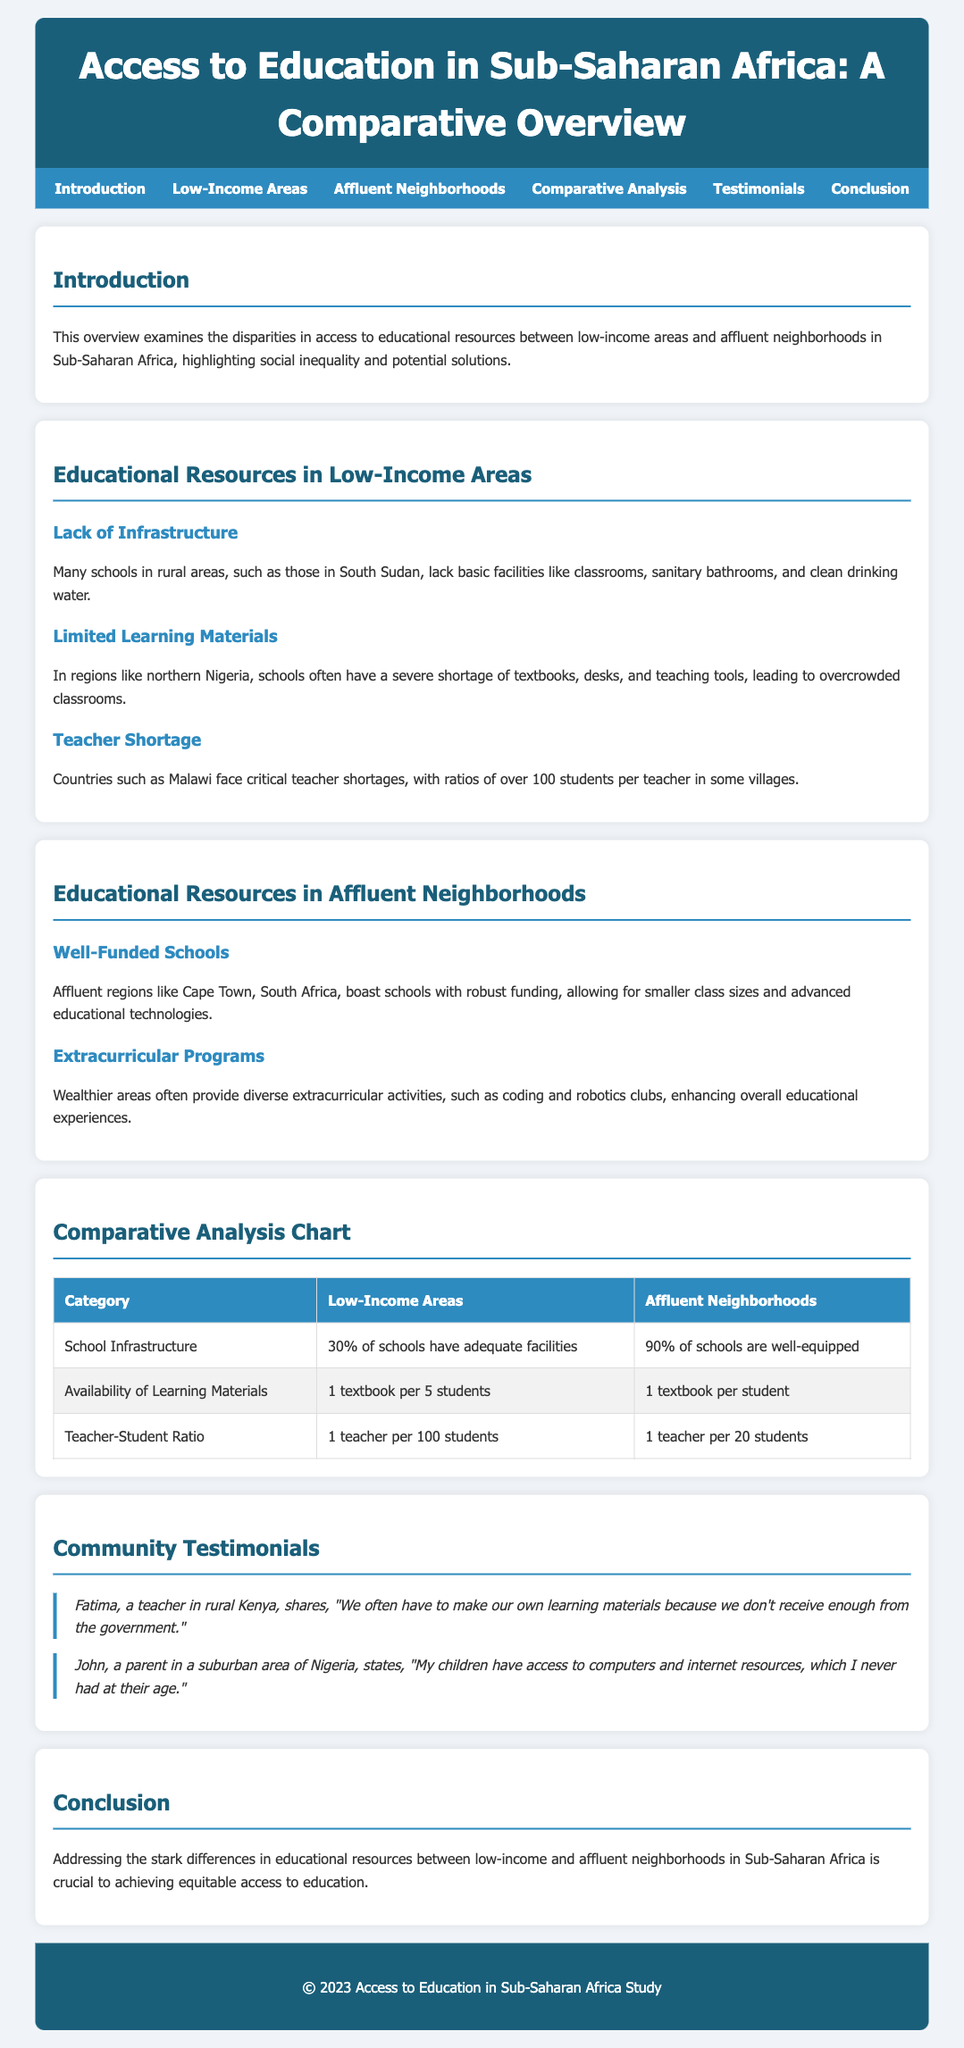What percentage of schools in low-income areas have adequate facilities? The document states that 30% of schools have adequate facilities in low-income areas.
Answer: 30% What is the teacher-student ratio in affluent neighborhoods? According to the comparative analysis chart, the ratio is 1 teacher per 20 students in affluent neighborhoods.
Answer: 1 teacher per 20 students What is one key issue faced by schools in rural South Sudan? The document mentions a lack of infrastructure, including basic facilities like classrooms and sanitary bathrooms.
Answer: Lack of infrastructure Who is Fatima, and what does she mention about learning materials? Fatima is a teacher in rural Kenya who states they often have to make their own learning materials.
Answer: A teacher in rural Kenya How many textbooks are available per student in affluent neighborhoods? The document indicates that there is 1 textbook per student in affluent neighborhoods.
Answer: 1 textbook per student Which area boasts well-funded schools according to the document? The document references Cape Town, South Africa, as an area with well-funded schools.
Answer: Cape Town, South Africa What is one extracurricular program mentioned for affluent areas? The document highlights coding and robotics clubs as an example of extracurricular programs offered in affluent areas.
Answer: Coding and robotics clubs What is the primary concern addressed in the conclusion? The conclusion emphasizes the need to address differences in educational resources to achieve equitable access to education.
Answer: Equitable access to education What is the primary focus of the document? The document focuses on disparities in access to educational resources between low-income areas and affluent neighborhoods in Sub-Saharan Africa.
Answer: Disparities in access to educational resources 